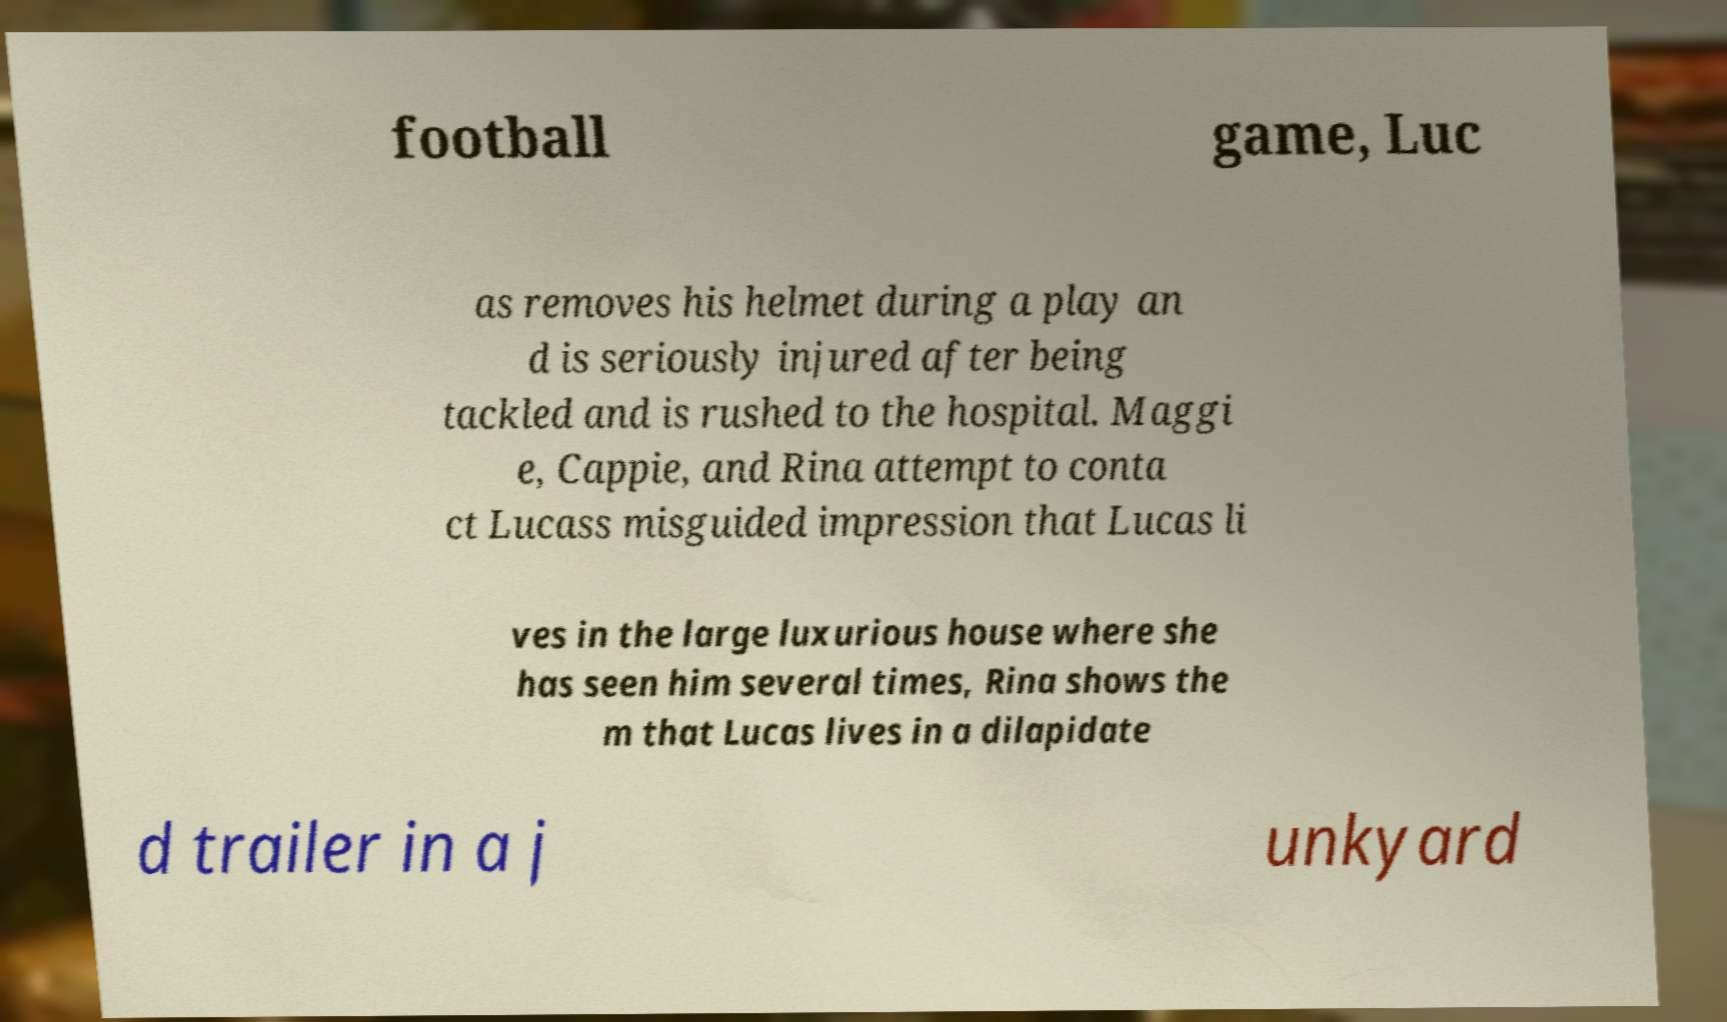Could you extract and type out the text from this image? football game, Luc as removes his helmet during a play an d is seriously injured after being tackled and is rushed to the hospital. Maggi e, Cappie, and Rina attempt to conta ct Lucass misguided impression that Lucas li ves in the large luxurious house where she has seen him several times, Rina shows the m that Lucas lives in a dilapidate d trailer in a j unkyard 